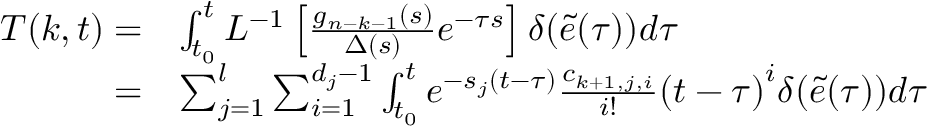Convert formula to latex. <formula><loc_0><loc_0><loc_500><loc_500>\begin{array} { r l } { T ( k , t ) = } & { { \int _ { { t _ { 0 } } } ^ { t } { { L ^ { - 1 } } \left [ { \frac { { { g _ { n - k - 1 } } ( s ) } } { \Delta ( s ) } } e ^ { - \tau s } \right ] \delta ( \tilde { e } ( \tau ) ) } d \tau } } \\ { = } & { \sum _ { j = 1 } ^ { l } { \sum _ { i = 1 } ^ { { d _ { j } } - 1 } { \int _ { { t _ { 0 } } } ^ { t } { { e ^ { - { s _ { j } } ( t - { \tau } ) } } \frac { { { c _ { k + 1 , j , i } } } } { i ! } { { ( t - \tau ) } ^ { i } } \delta ( \tilde { e } ( \tau ) ) d \tau } } } } \end{array}</formula> 